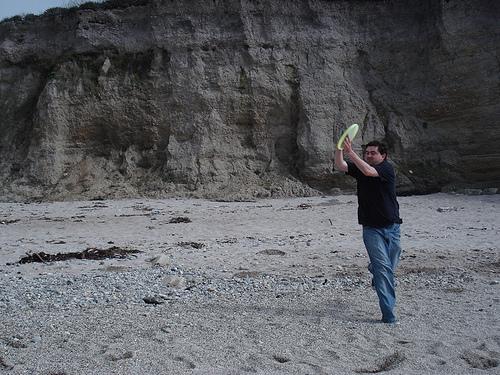What is this man doing?
Quick response, please. Playing frisbee. What color are the pants?
Keep it brief. Blue. What is this person doing?
Quick response, please. Playing frisbee. Why has the man raised his arms?
Concise answer only. Frisbee. Which way is the shadow cast?
Keep it brief. Left. Is this a Snow Hill?
Answer briefly. No. What kind of scene is this man in?
Write a very short answer. Beach. What is the man doing?
Keep it brief. Catching frisbee. Could this scene be in Iowa?
Keep it brief. No. Is there a hat in the picture?
Short answer required. No. Does the man have any ink on him?
Answer briefly. No. What's he doing?
Be succinct. Catching frisbee. Is this man falling?
Be succinct. No. 